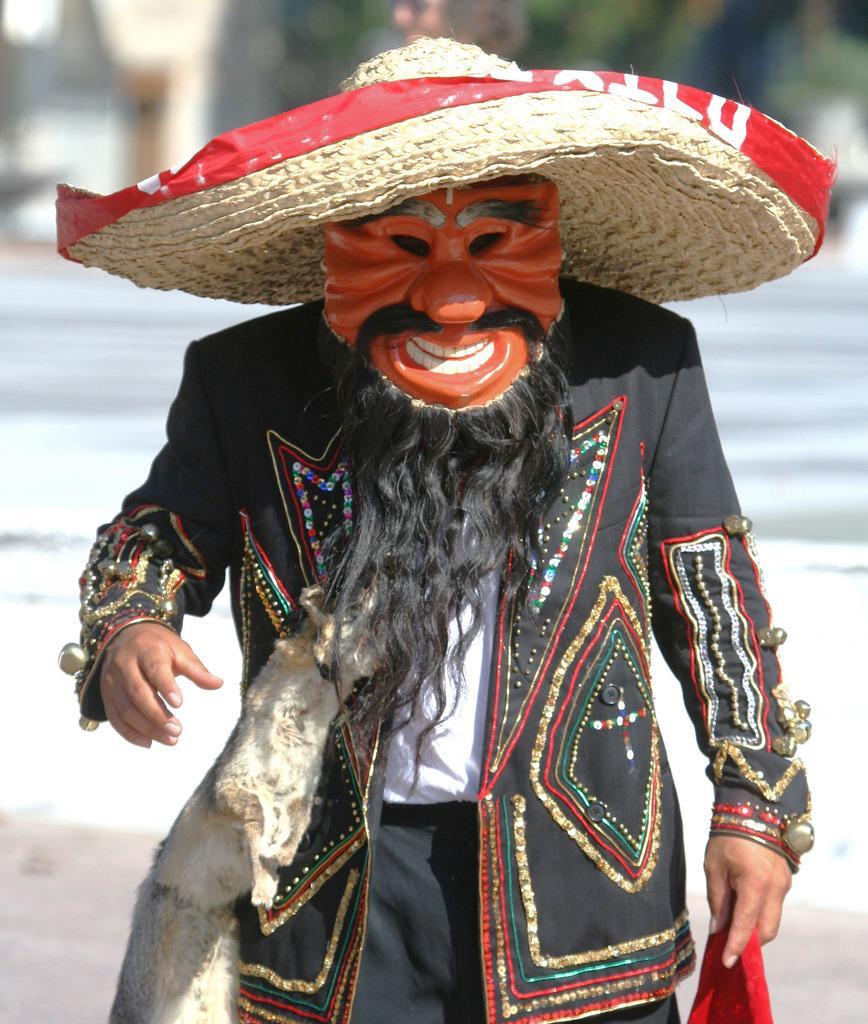Can you describe this image briefly? In the center of the image we can see a person is standing and wearing mask, coat, hat and holding a cloth. At the bottom of the image we can see the ground. In the background the image blur. 